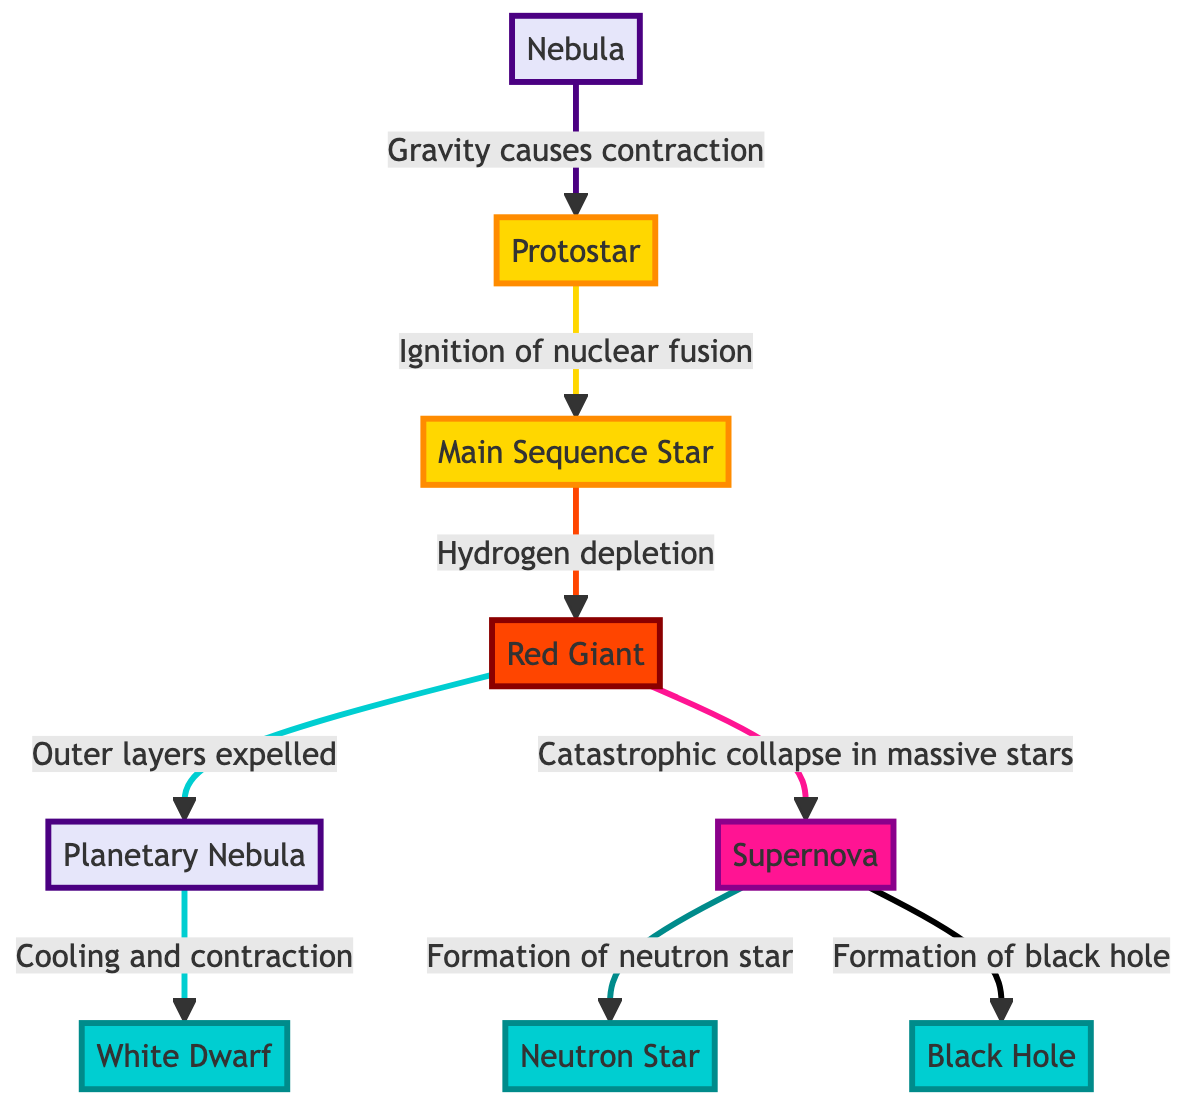What is the first stage of star formation? The diagram starts with the node labeled "Nebula," which is the first step in the star formation process.
Answer: Nebula Which stage comes after the Protostar? Following the "Protostar," the next node in the diagram is "Main Sequence Star." This is the direct successor in the sequence.
Answer: Main Sequence Star How many final outcomes are there after the Supernova? The diagram shows that after "Supernova," there are two distinct outcomes: "Neutron Star" and "Black Hole." This indicates there are two final states possible.
Answer: 2 What process leads a Main Sequence Star to become a Red Giant? The transition from "Main Sequence Star" to "Red Giant" occurs due to "Hydrogen depletion," a key factor leading to the next phase in stellar evolution.
Answer: Hydrogen depletion What happens to a Red Giant after its outer layers are expelled? After the outer layers are expelled from a "Red Giant," the next stage shown in the diagram is "Planetary Nebula," indicating the result of this process.
Answer: Planetary Nebula Which stage is characterized by a catastrophic collapse in massive stars? The diagram specifies that a "Supernova" occurs in the context of a catastrophic collapse of massive stars, identifying this event's relationship to such star types.
Answer: Supernova What color represents the Protostar in the diagram? The "Protostar" node is represented in a golden hue (#FFD700), marking its position within the diagram visually.
Answer: Gold What is the last stage a massive star can achieve after a Supernova? According to the diagram, the last stage possible for a massive star after a Supernova is either a "Neutron Star" or a "Black Hole," which are outcomes depending on the mass of the original star.
Answer: Neutron Star or Black Hole What links the stages of Nebula and Protostar? The stage transition from "Nebula" to "Protostar" is linked by the phrase "Gravity causes contraction," which describes the process leading to the formation of a Protostar.
Answer: Gravity causes contraction 